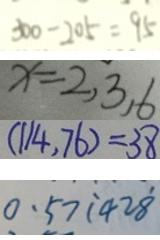Convert formula to latex. <formula><loc_0><loc_0><loc_500><loc_500>3 0 0 - 2 0 5 = 9 5 
 x = 2 , 3 , 6 
 ( 1 1 4 . 7 6 ) = 3 8 
 0 . 5 7 \dot { 1 } 4 2 \dot { 8 }</formula> 